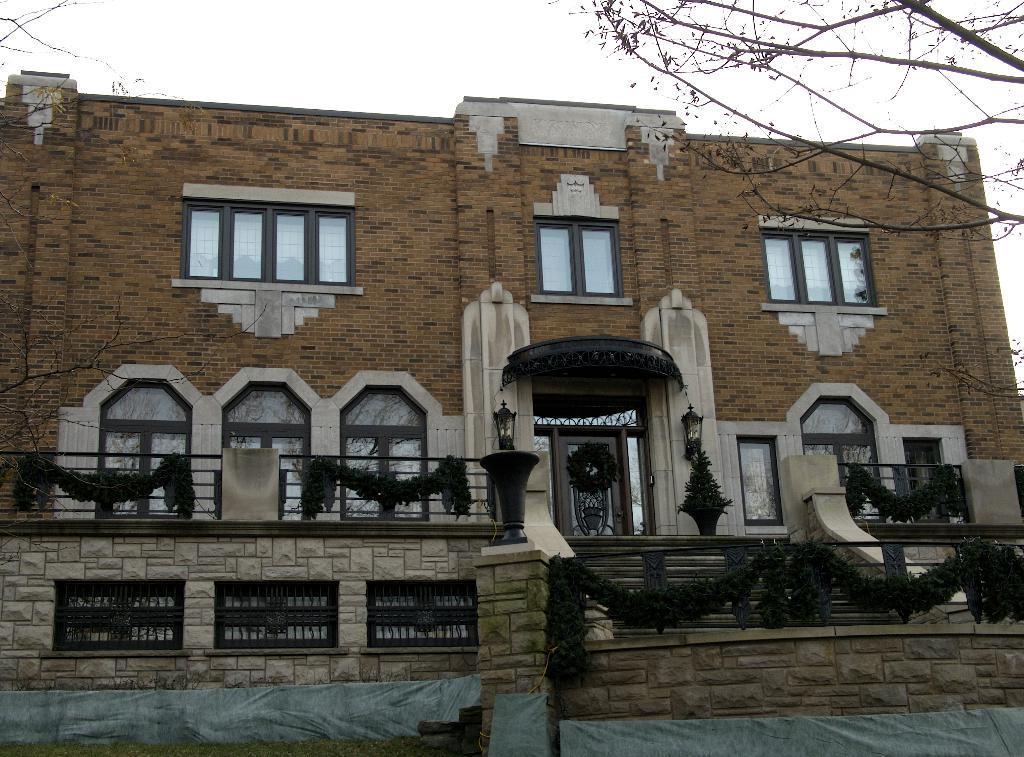Can you describe this image briefly? In the image we can see a building and the windows of the building. There are lamps, stairs, tree branches and a white sky. 